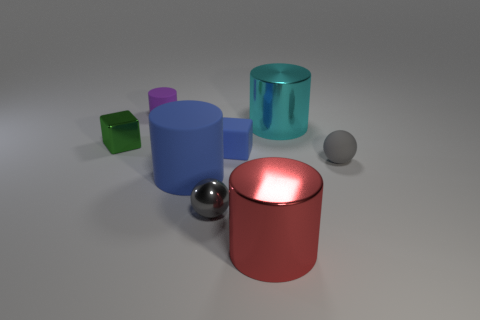Subtract all green cylinders. Subtract all red cubes. How many cylinders are left? 4 Add 2 tiny rubber spheres. How many objects exist? 10 Subtract all balls. How many objects are left? 6 Subtract all red blocks. Subtract all matte things. How many objects are left? 4 Add 8 blue matte things. How many blue matte things are left? 10 Add 4 small metal objects. How many small metal objects exist? 6 Subtract 0 green spheres. How many objects are left? 8 